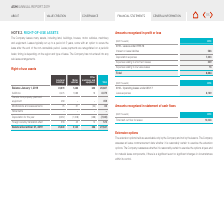According to Asm International Nv's financial document, What is the lease duration for the company? typically run up to a period of 5 years. The document states: "and equipment. Leases typically run up to a period of 5 years, some with an option to renew the..." Also, What are the types of assets included in the table? The document contains multiple relevant values: Land and buildings, Motor vehicles, Other machinery and equipment. From the document: "Land and buildings Motor vehicles Other machinery and equipment Total s many assets, including land, buildings, houses, motor vehicles, machinery..." Also, What is the total balance in january 1, 2019? According to the financial document, 25,687. The relevant text states: "Balance January 1, 2019 23,579 1,488 620 25,687..." Additionally, Which type of asset had the greatest depreciation for the year? According to the financial document, Land and buildings. The relevant text states: "Land and buildings Motor vehicles..." Also, can you calculate: What is the average depreciation for the year for the assets? To answer this question, I need to perform calculations using the financial data. The calculation is: -7,333/3, which equals -2444.33. This is based on the information: "Depreciation for the year (6,057) (1,008) (268) (7,333) Depreciation for the year (6,057) (1,008) (268) (7,333)..." The key data points involved are: 7,333. Also, can you calculate: What is the change in total Balance from January 1, 2019 to December 31, 2019  Based on the calculation:  27,547 - 25,687 , the result is 1860. This is based on the information: "Balance January 1, 2019 23,579 1,488 620 25,687 Balance December 31, 2019 25,049 2,142 356 27,547..." The key data points involved are: 25,687, 27,547. 